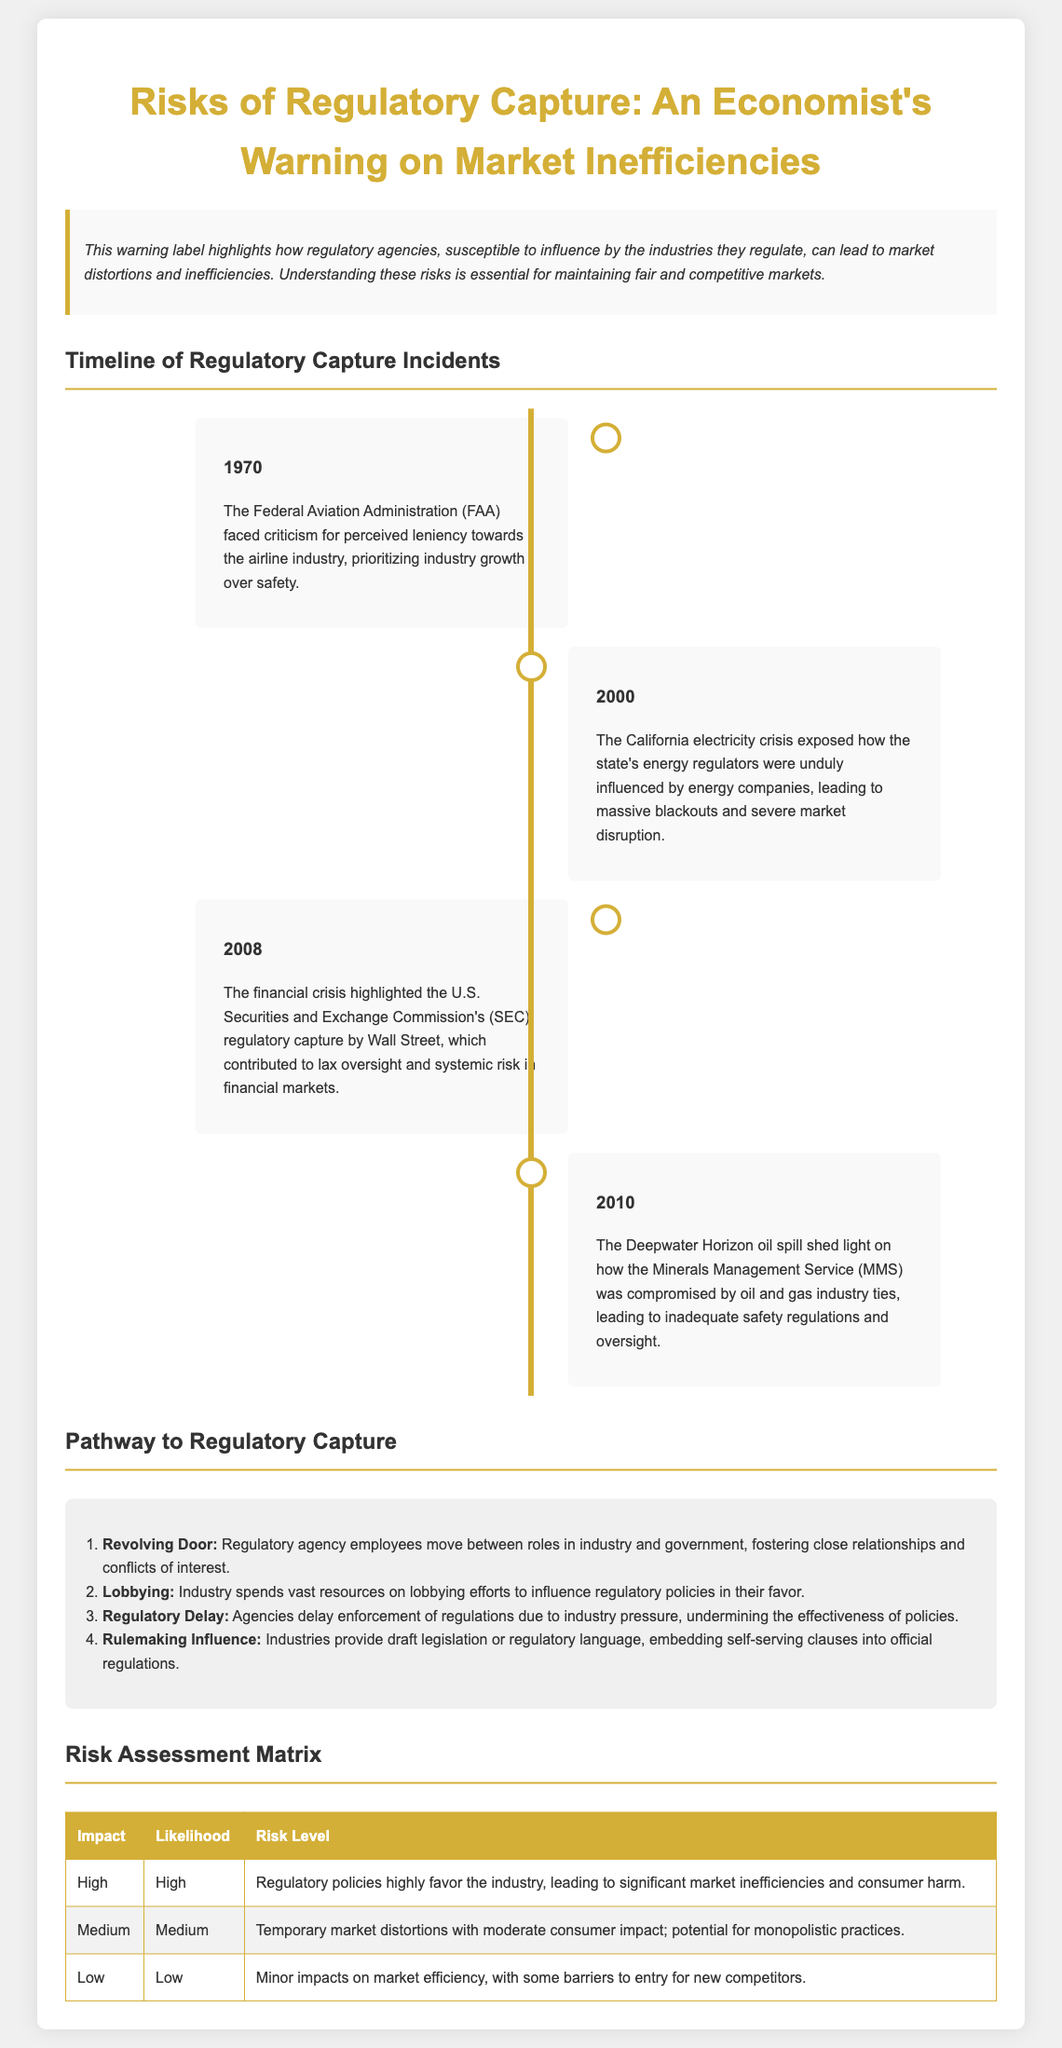What year did the FAA face criticism? The timeline indicates that the FAA faced criticism in 1970 due to perceived leniency towards the airline industry.
Answer: 1970 What incident highlighted the influence of energy companies on regulators? The California electricity crisis in 2000 is mentioned as a significant incident of regulatory capture involving energy companies.
Answer: California electricity crisis Which agency was influenced by Wall Street during the financial crisis? The document refers to the U.S. Securities and Exchange Commission (SEC) being influenced by Wall Street during the 2008 financial crisis.
Answer: SEC What is the risk level associated with high impact and high likelihood? The risk assessment matrix states that high impact and high likelihood leads to regulatory policies highly favoring the industry, resulting in significant market inefficiencies.
Answer: Regulatory policies highly favor the industry How many incidents of regulatory capture are detailed in the timeline? The timeline lists a total of four significant incidents of regulatory capture across different years.
Answer: Four What term describes the movement of regulatory agency employees between industry and government? The pathway to regulatory capture refers to the "Revolving Door," which describes this movement fostering close relationships.
Answer: Revolving Door What is the first step in the pathway to regulatory capture? The infographic identifies "Revolving Door" as the first step in the pathway that leads to regulatory capture.
Answer: Revolving Door What color is used for the timeline's background? The timeline has a white background, contrasting with the content's background color.
Answer: White What represents the highest risk level in the matrix? The matrix categorizes "Regulatory policies highly favor the industry" as the highest risk level under high impact and high likelihood.
Answer: Regulatory policies highly favor the industry 